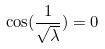Convert formula to latex. <formula><loc_0><loc_0><loc_500><loc_500>\cos ( \frac { 1 } { \sqrt { \lambda } } ) = 0</formula> 